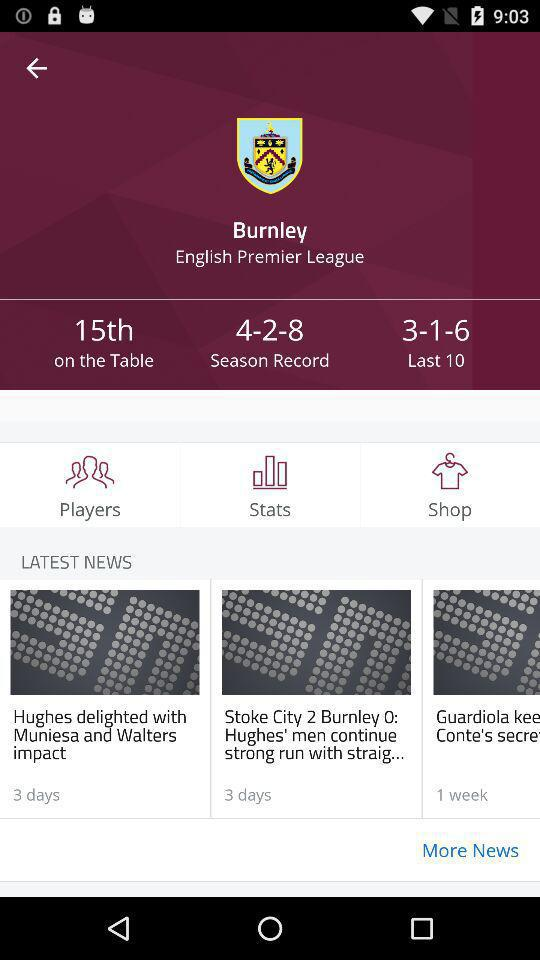When was the "Hughes delighted with Muniesa and Walters impact" news posted? The news was posted 3 days ago. 